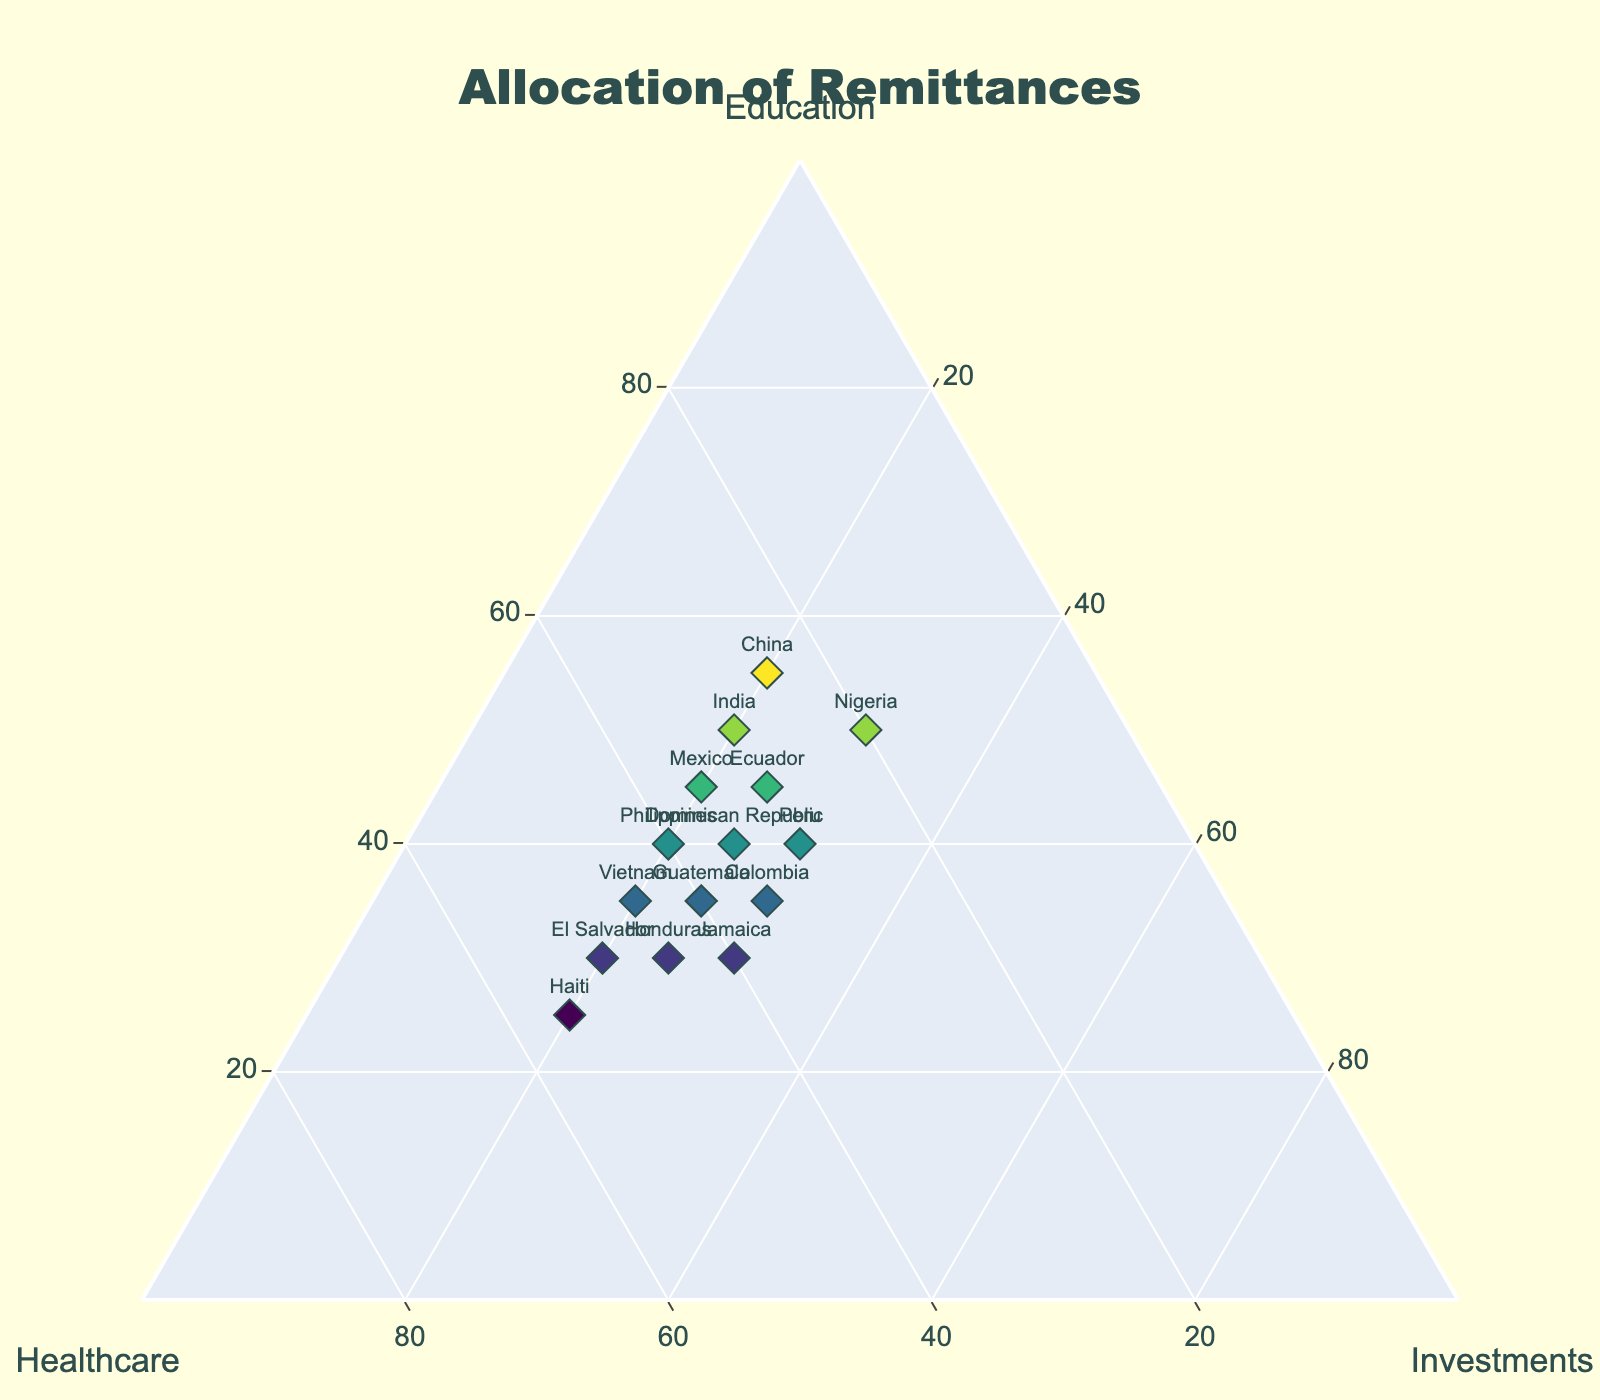What is the title of the figure? The title is the large text at the top center of the figure that summarizes the content being depicted.
Answer: Allocation of Remittances Which country allocates the highest percentage of remittances to education? To find the country with the highest percentage for education, look at the "Education" axis and identify the highest value.
Answer: China How many countries allocate more than 40% of remittances to healthcare? Look at the plotted points' positions along the "Healthcare" axis and count the countries with values above 40%.
Answer: Five Which country has the highest allocation to healthcare? To determine this, find the highest value on the "Healthcare" axis and see the corresponding country.
Answer: Haiti What is the sum of percentages allocated to education and investments by Nigeria? Add the percentages of education and investments given for Nigeria. Education is 50% and investments is 30%, so 50% + 30% = 80%.
Answer: 80% Which country has equal percentages allocated to education and healthcare? Identify the point on the figure where the percentages of education and healthcare are the same.
Answer: Philippines Is there a country with more than 50% allocated to education? If so, which one? Check the "Education" axis for values greater than 50% and identify the corresponding country.
Answer: Yes, China How do the remittance allocations for education compare between Mexico and Nigeria? Refer to the "Education" axis values for Mexico and Nigeria and compare them. Mexico has 45% while Nigeria has 50%.
Answer: Nigeria allocates 5% more to education than Mexico Which two countries allocate the same percentage to investments? Locate countries with the same value on the "Investments" axis. All countries in the data allocate either 20%, 25%, or 30% to investments.
Answer: Many pairs, e.g., Peru and Colombia (both 30%) What is the range of remittance allocation to healthcare across all countries? Determine the minimum and maximum values on the "Healthcare" axis. The minimum is 20% (Nigeria), and the maximum is 55% (Haiti). Range = 55% - 20% = 35%.
Answer: 35% 